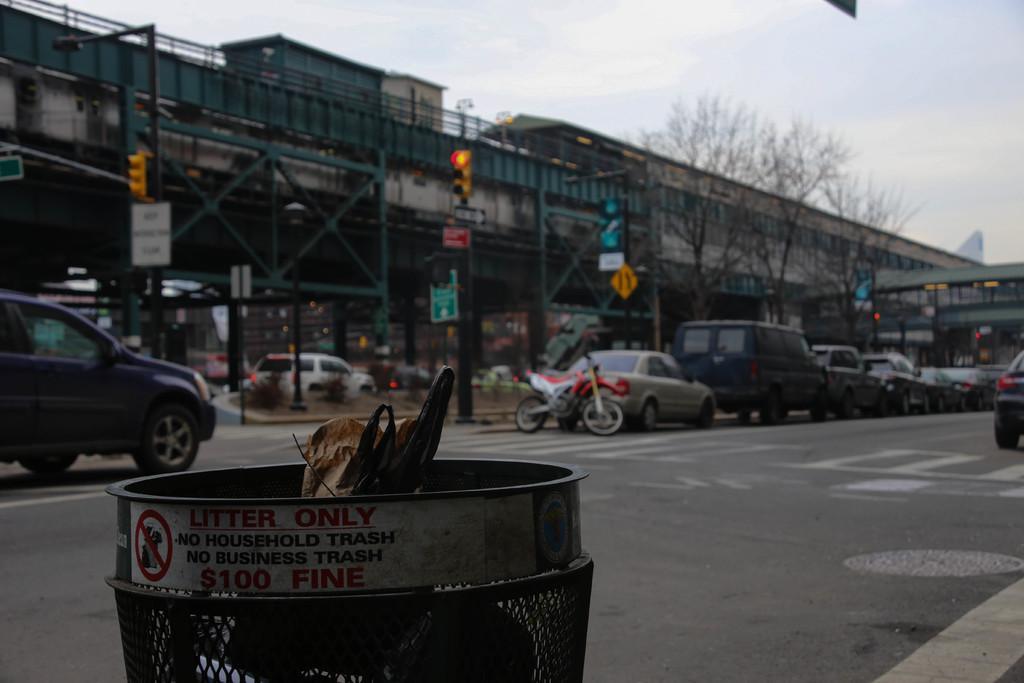Can you describe this image briefly? In the image there are few vehicles on the road with a dustbin in the front, in the back there are buildings, there is a traffic light in the middle and above its sky. 